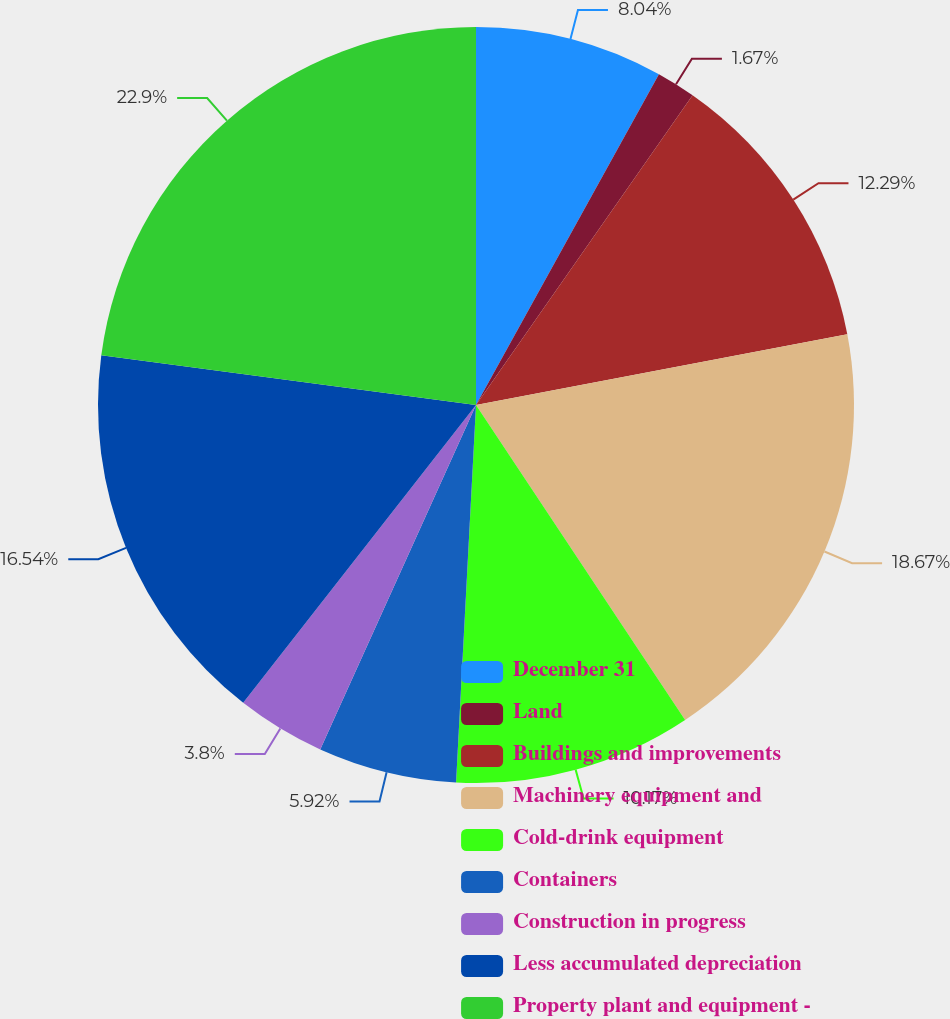<chart> <loc_0><loc_0><loc_500><loc_500><pie_chart><fcel>December 31<fcel>Land<fcel>Buildings and improvements<fcel>Machinery equipment and<fcel>Cold-drink equipment<fcel>Containers<fcel>Construction in progress<fcel>Less accumulated depreciation<fcel>Property plant and equipment -<nl><fcel>8.04%<fcel>1.67%<fcel>12.29%<fcel>18.67%<fcel>10.17%<fcel>5.92%<fcel>3.8%<fcel>16.54%<fcel>22.9%<nl></chart> 